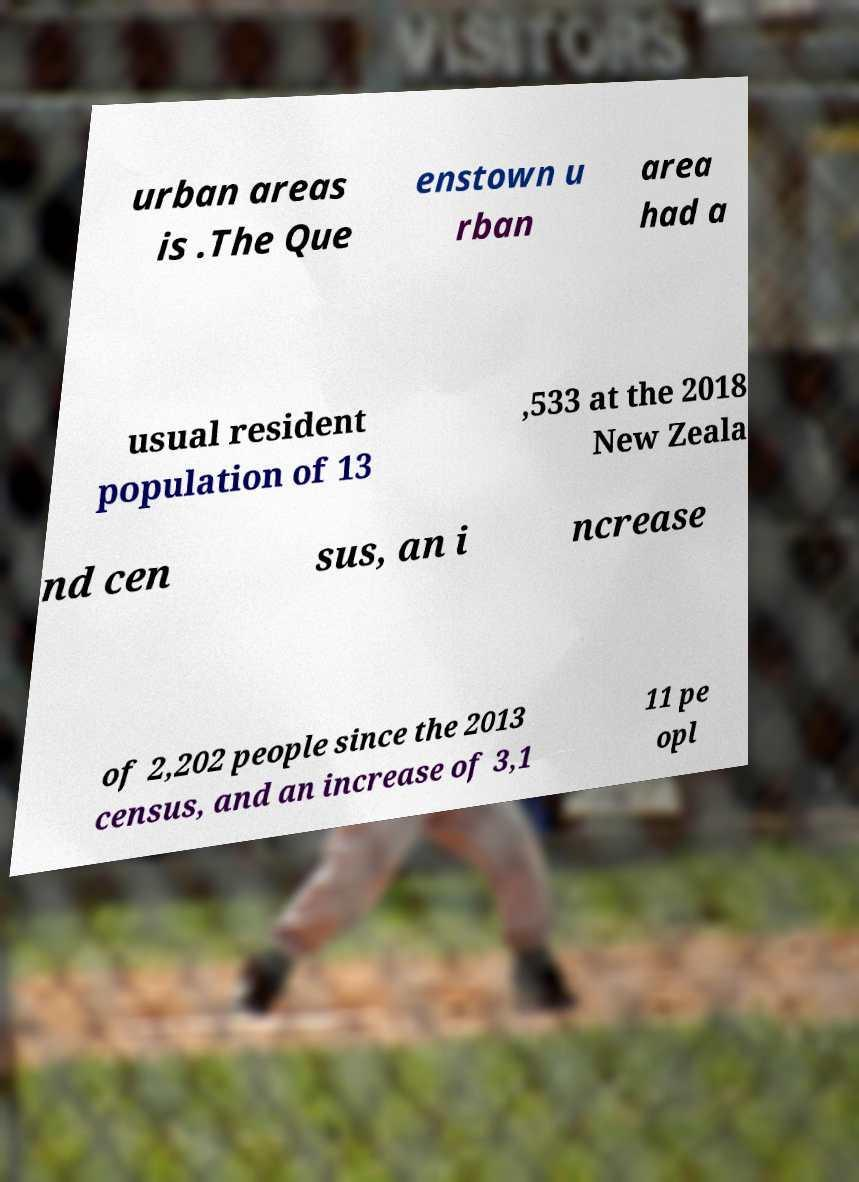I need the written content from this picture converted into text. Can you do that? urban areas is .The Que enstown u rban area had a usual resident population of 13 ,533 at the 2018 New Zeala nd cen sus, an i ncrease of 2,202 people since the 2013 census, and an increase of 3,1 11 pe opl 